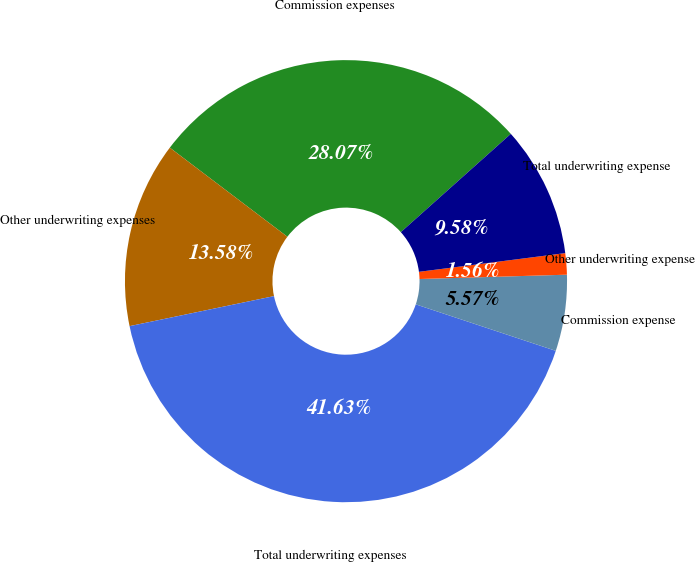Convert chart. <chart><loc_0><loc_0><loc_500><loc_500><pie_chart><fcel>Commission expenses<fcel>Other underwriting expenses<fcel>Total underwriting expenses<fcel>Commission expense<fcel>Other underwriting expense<fcel>Total underwriting expense<nl><fcel>28.07%<fcel>13.58%<fcel>41.63%<fcel>5.57%<fcel>1.56%<fcel>9.58%<nl></chart> 